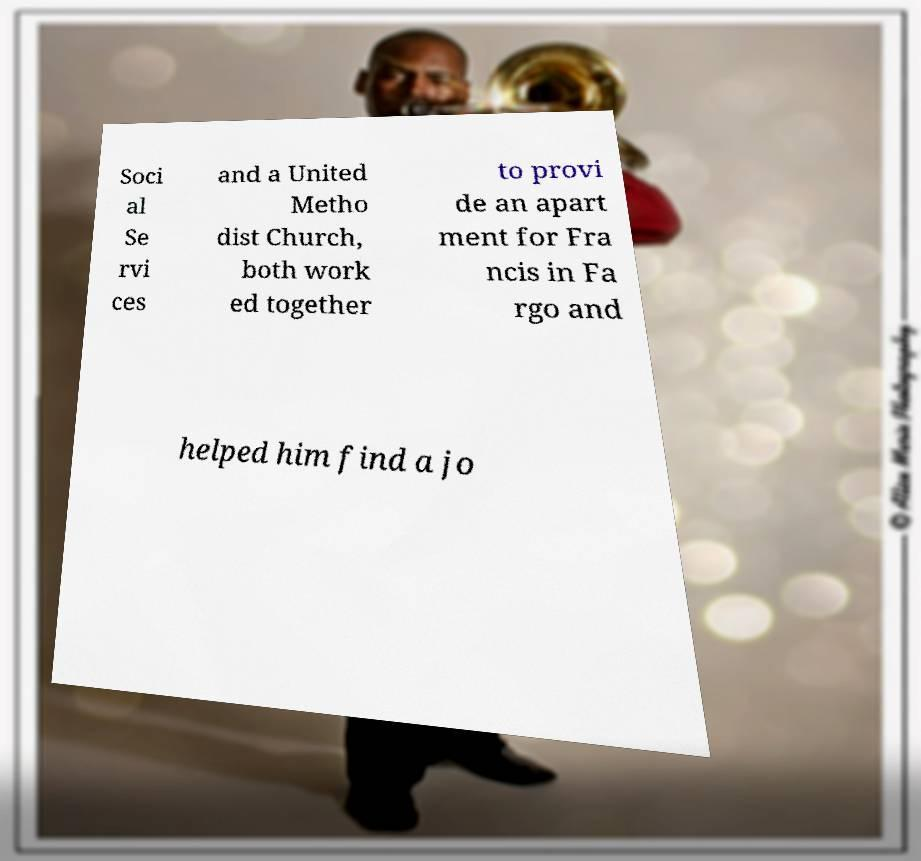Could you extract and type out the text from this image? Soci al Se rvi ces and a United Metho dist Church, both work ed together to provi de an apart ment for Fra ncis in Fa rgo and helped him find a jo 